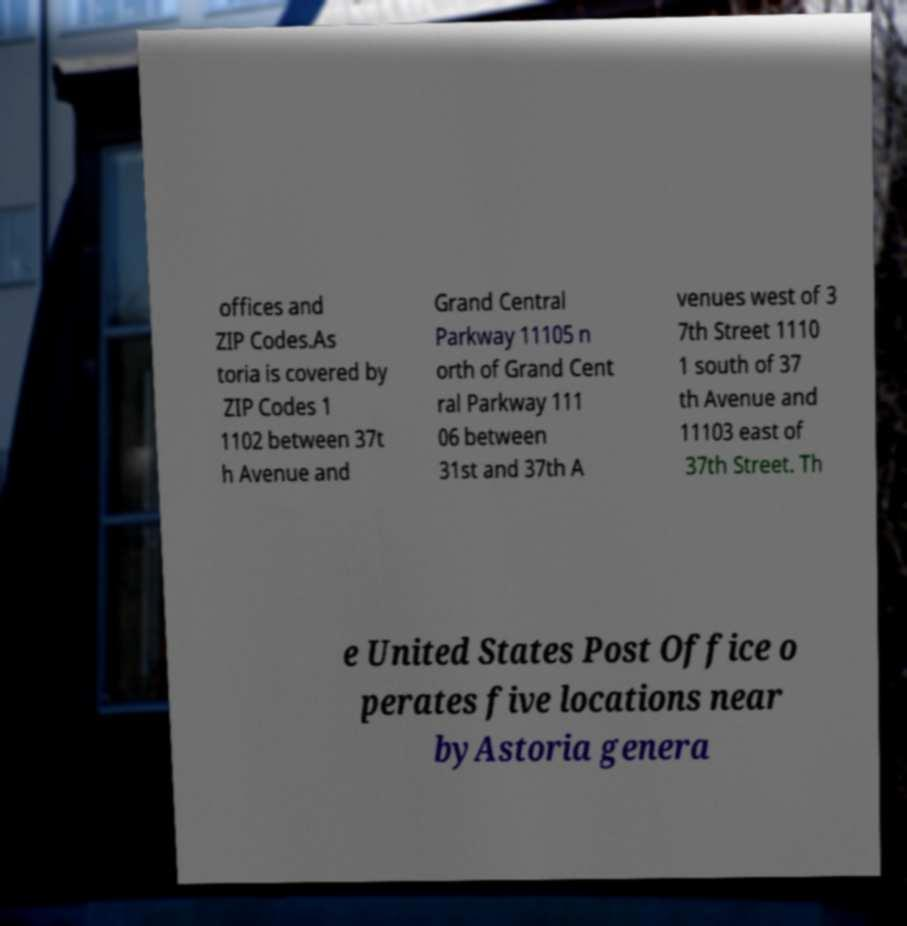There's text embedded in this image that I need extracted. Can you transcribe it verbatim? offices and ZIP Codes.As toria is covered by ZIP Codes 1 1102 between 37t h Avenue and Grand Central Parkway 11105 n orth of Grand Cent ral Parkway 111 06 between 31st and 37th A venues west of 3 7th Street 1110 1 south of 37 th Avenue and 11103 east of 37th Street. Th e United States Post Office o perates five locations near byAstoria genera 